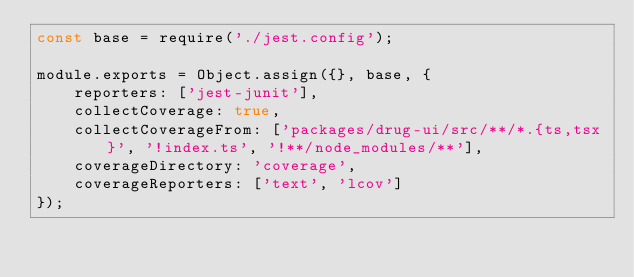<code> <loc_0><loc_0><loc_500><loc_500><_JavaScript_>const base = require('./jest.config');

module.exports = Object.assign({}, base, {
    reporters: ['jest-junit'],
    collectCoverage: true,
    collectCoverageFrom: ['packages/drug-ui/src/**/*.{ts,tsx}', '!index.ts', '!**/node_modules/**'],
    coverageDirectory: 'coverage',
    coverageReporters: ['text', 'lcov']
});
</code> 